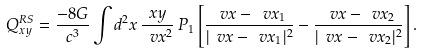<formula> <loc_0><loc_0><loc_500><loc_500>Q ^ { R S } _ { x y } = \frac { - 8 G } { c ^ { 3 } } \int d ^ { 2 } x \, \frac { x y } { \ v x ^ { 2 } } \, { P } _ { 1 } \left [ \frac { \ v x - \ v x _ { 1 } } { | \ v x - \ v x _ { 1 } | ^ { 2 } } - \frac { \ v x - \ v x _ { 2 } } { | \ v x - \ v x _ { 2 } | ^ { 2 } } \right ] .</formula> 